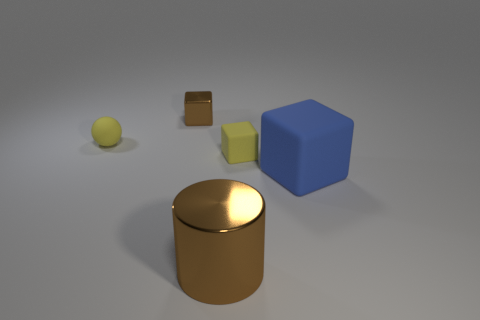There is a rubber object that is to the right of the yellow rubber thing on the right side of the rubber sphere; is there a metallic thing in front of it?
Your answer should be very brief. Yes. What number of big green things are there?
Your answer should be very brief. 0. How many things are either tiny rubber things to the right of the metal cylinder or yellow objects to the right of the big cylinder?
Keep it short and to the point. 1. There is a brown shiny object in front of the brown cube; is its size the same as the large matte thing?
Offer a terse response. Yes. The brown thing that is the same shape as the blue matte object is what size?
Provide a short and direct response. Small. There is a cylinder that is the same size as the blue rubber object; what is its material?
Ensure brevity in your answer.  Metal. There is a brown object that is the same shape as the blue rubber thing; what is its material?
Offer a very short reply. Metal. What number of other objects are there of the same size as the cylinder?
Your response must be concise. 1. There is another object that is the same color as the tiny shiny object; what size is it?
Ensure brevity in your answer.  Large. What number of tiny things are the same color as the large cylinder?
Your answer should be compact. 1. 